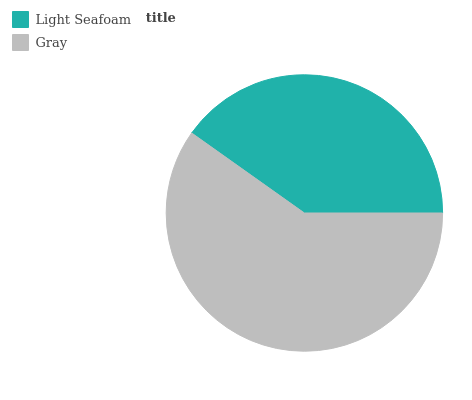Is Light Seafoam the minimum?
Answer yes or no. Yes. Is Gray the maximum?
Answer yes or no. Yes. Is Gray the minimum?
Answer yes or no. No. Is Gray greater than Light Seafoam?
Answer yes or no. Yes. Is Light Seafoam less than Gray?
Answer yes or no. Yes. Is Light Seafoam greater than Gray?
Answer yes or no. No. Is Gray less than Light Seafoam?
Answer yes or no. No. Is Gray the high median?
Answer yes or no. Yes. Is Light Seafoam the low median?
Answer yes or no. Yes. Is Light Seafoam the high median?
Answer yes or no. No. Is Gray the low median?
Answer yes or no. No. 